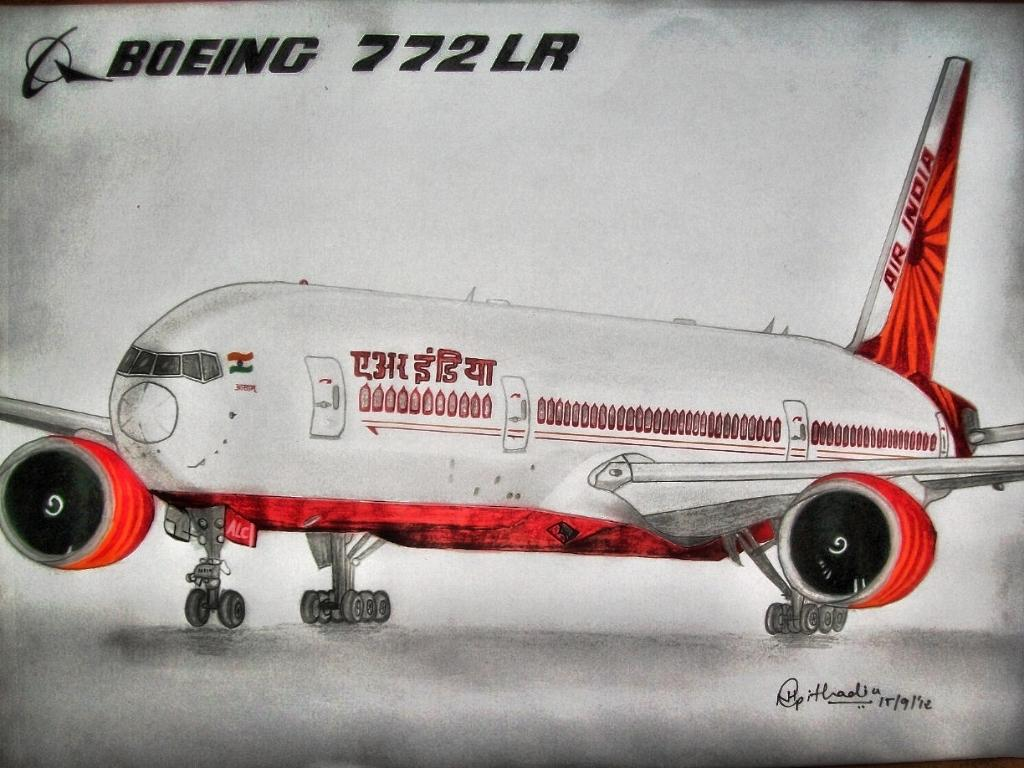What is the main subject of the picture? The main subject of the picture is an aircraft. Can you describe any additional features or elements in the image? Yes, there is a watermark on the top of the image and text in the bottom right corner of the image. How many cows are grazing in the background of the image? There are no cows present in the image; it features an aircraft with a watermark and text. 